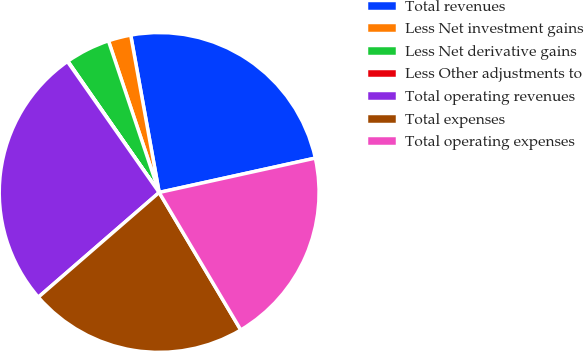Convert chart to OTSL. <chart><loc_0><loc_0><loc_500><loc_500><pie_chart><fcel>Total revenues<fcel>Less Net investment gains<fcel>Less Net derivative gains<fcel>Less Other adjustments to<fcel>Total operating revenues<fcel>Total expenses<fcel>Total operating expenses<nl><fcel>24.4%<fcel>2.29%<fcel>4.54%<fcel>0.05%<fcel>26.64%<fcel>22.16%<fcel>19.92%<nl></chart> 